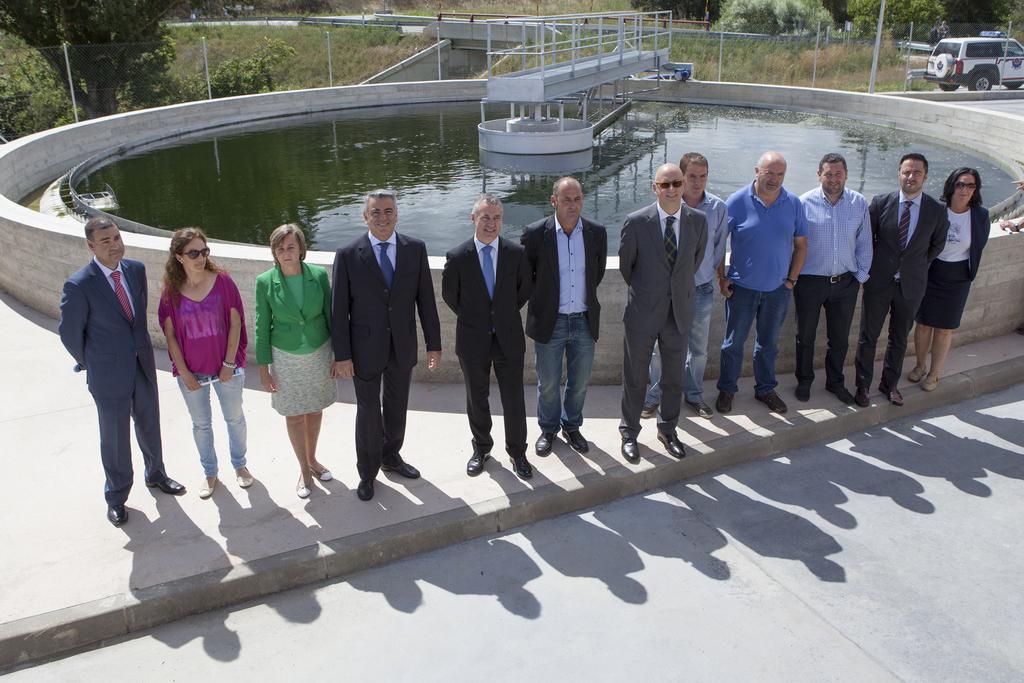In one or two sentences, can you explain what this image depicts? In this image there are people, water, mesh, vehicle, trees, poles and objects. 